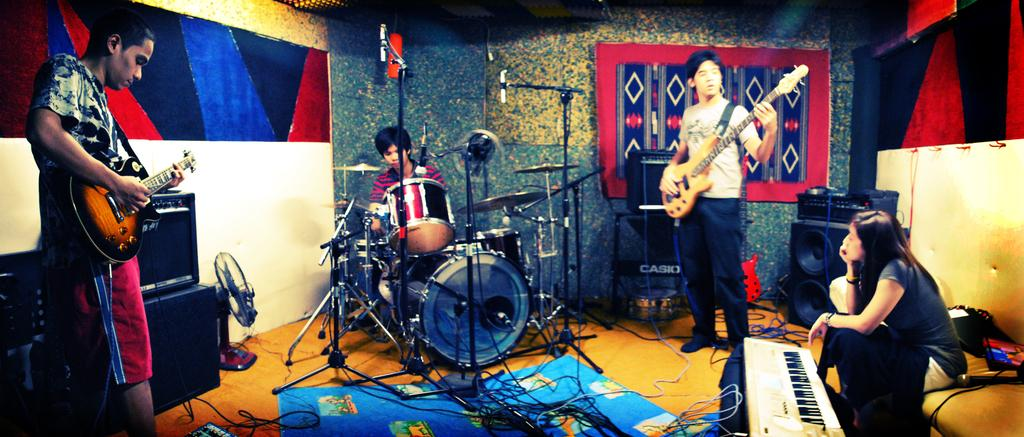How many people are in the image? There are four people in the image: three men and one woman. What are the men doing in the image? The men are standing and playing musical instruments. What is the woman doing in the image? The woman is sitting and playing a piano. What type of hammer can be seen in the woman's hand in the image? There is no hammer present in the image; the woman is playing a piano. Can you describe the detail on the men's shoes in the image? There is no information provided about the men's shoes, so it is not possible to describe any details. 